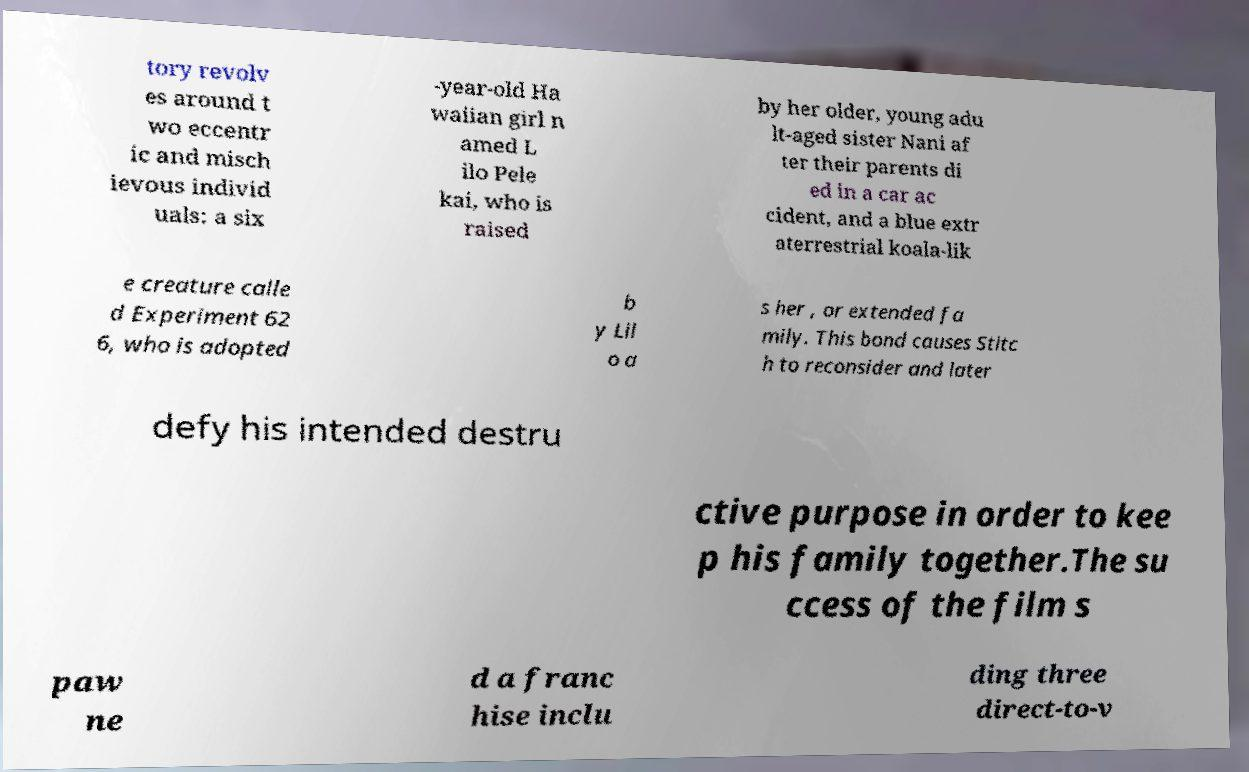What messages or text are displayed in this image? I need them in a readable, typed format. tory revolv es around t wo eccentr ic and misch ievous individ uals: a six -year-old Ha waiian girl n amed L ilo Pele kai, who is raised by her older, young adu lt-aged sister Nani af ter their parents di ed in a car ac cident, and a blue extr aterrestrial koala-lik e creature calle d Experiment 62 6, who is adopted b y Lil o a s her , or extended fa mily. This bond causes Stitc h to reconsider and later defy his intended destru ctive purpose in order to kee p his family together.The su ccess of the film s paw ne d a franc hise inclu ding three direct-to-v 